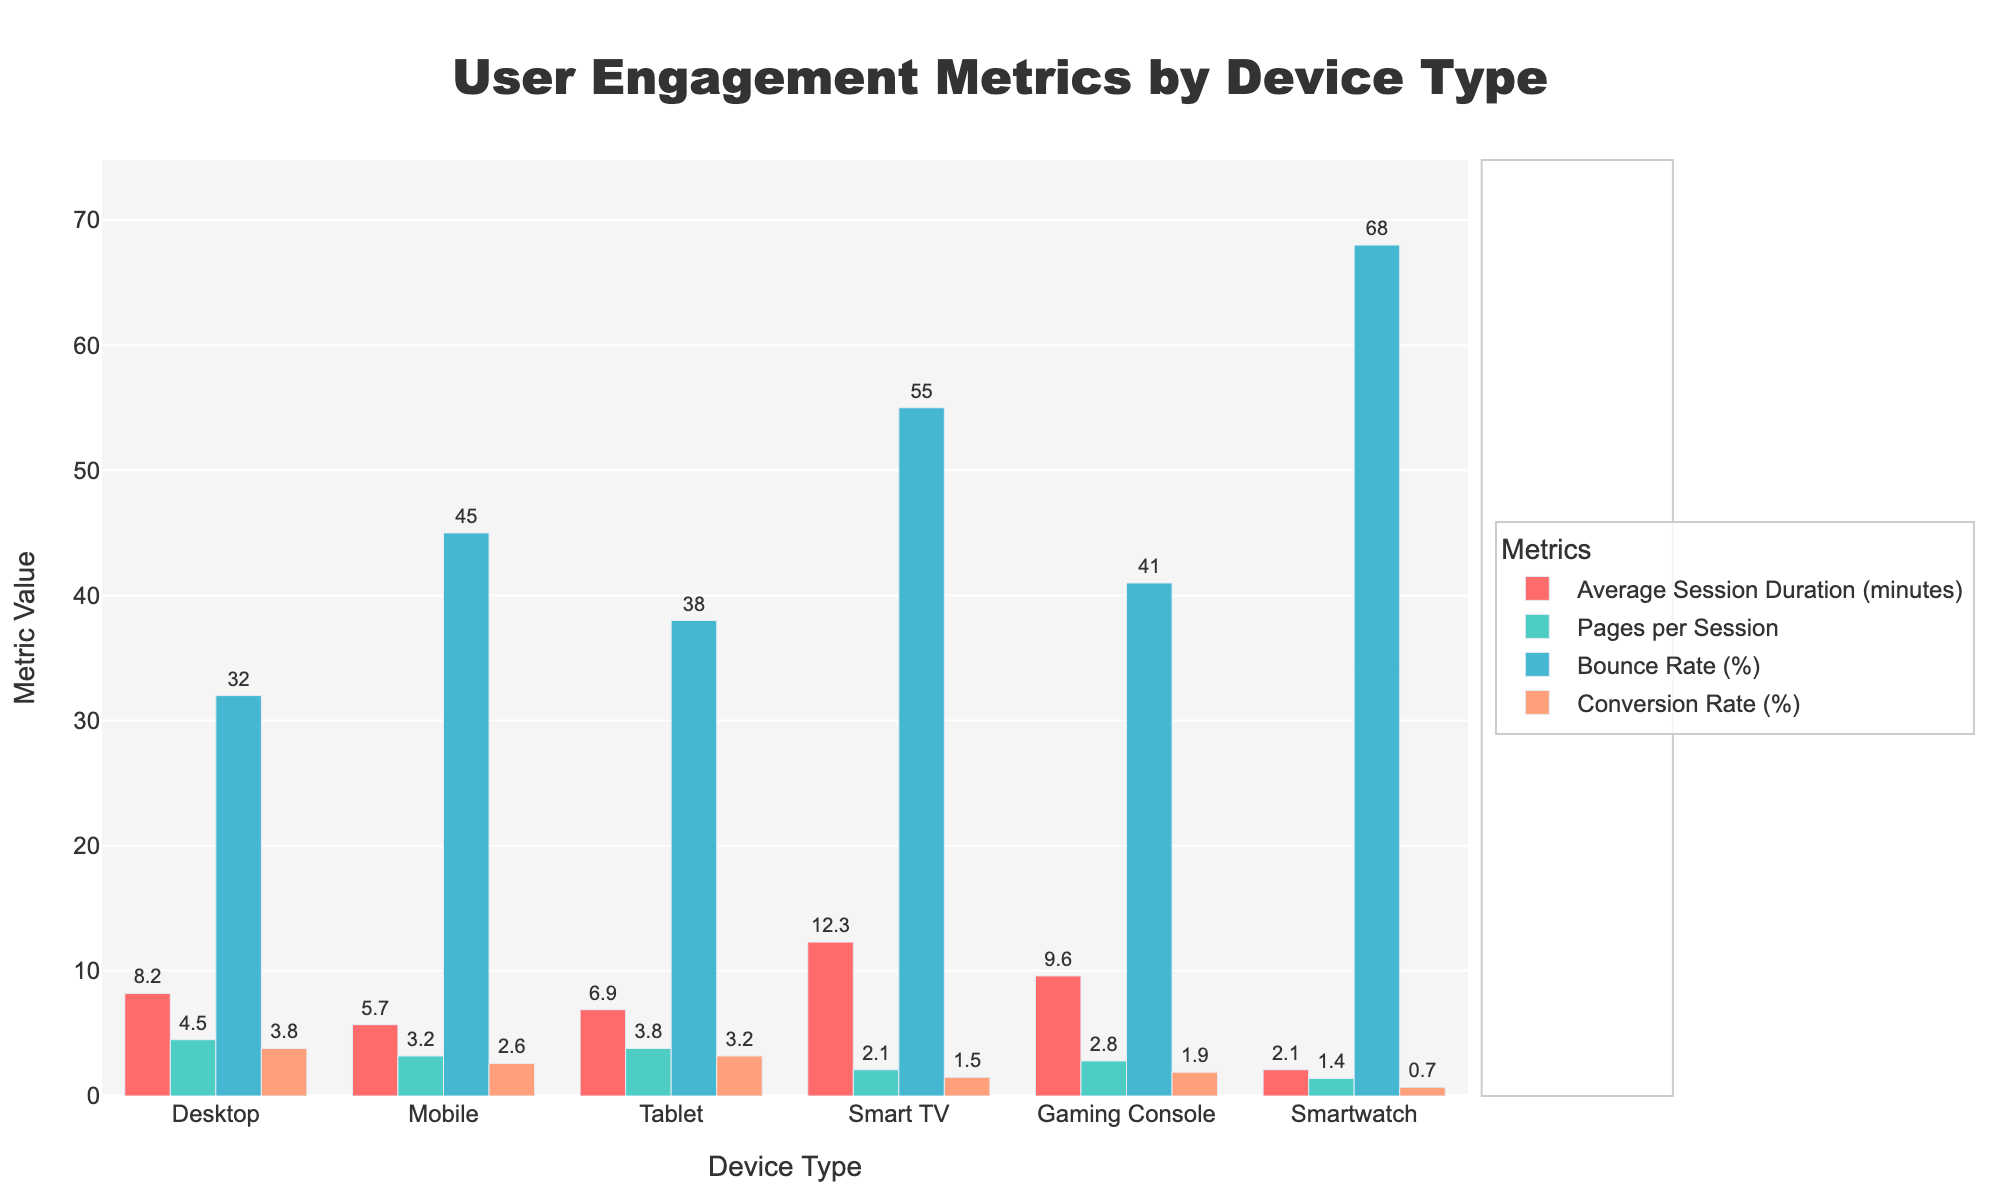Which device type has the highest average session duration? In the figure, compare the heights of the bars corresponding to 'Average Session Duration (minutes)' across all device types. The 'Smart TV' has the tallest bar.
Answer: Smart TV Which device type has the highest bounce rate? In the figure, compare the heights of the bars corresponding to 'Bounce Rate (%)' across all device types. The 'Smartwatch' has the tallest bar.
Answer: Smartwatch Which metric has the lowest value for Smartwatch? In the figure, look at the bars for the Smartwatch across all metrics. The shortest bar is for 'Conversion Rate (%)'.
Answer: Conversion Rate (%) How much higher is the average session duration on Gaming Console compared to Mobile? Look at the heights of the bars for 'Average Session Duration (minutes)' for both Gaming Console and Mobile. Subtract the Mobile value (5.7) from the Gaming Console value (9.6). So, 9.6 - 5.7 = 3.9.
Answer: 3.9 What is the difference in conversion rate between Tablet and Desktop? Compare the 'Conversion Rate (%)' bars for Tablet and Desktop. Subtract the Desktop value (3.8) from the Tablet value (3.2). So, 3.8 - 3.2 = 0.6.
Answer: 0.6 Which device type has the lowest pages per session? Compare the heights of the bars corresponding to 'Pages per Session' across all device types. The 'Smartwatch' has the shortest bar.
Answer: Smartwatch What is the sum of bounce rates for Mobile and Tablet? Add the values of the 'Bounce Rate (%)' bars corresponding to Mobile (45) and Tablet (38). 45 + 38 = 83.
Answer: 83 How much longer do users spend on Desktop compared to Tablet on average? Look at the 'Average Session Duration (minutes)' bars for Desktop and Tablet. Subtract the Tablet value (6.9) from the Desktop value (8.2). So, 8.2 - 6.9 = 1.3.
Answer: 1.3 Which device types have a higher bounce rate than 40%? Identify the 'Bounce Rate (%)' bars that exceed 40%. These are Mobile (45), Tablet (38), Smart TV (55), Gaming Console (41), and Smartwatch (68). Remove Tablet with 38%.
Answer: Mobile, Smart TV, Gaming Console, Smartwatch Which metric is represented by a green bar? Examine the legend in the figure to identify which metric corresponds to the green bar. 'Pages per Session' is represented by a green bar.
Answer: Pages per Session 